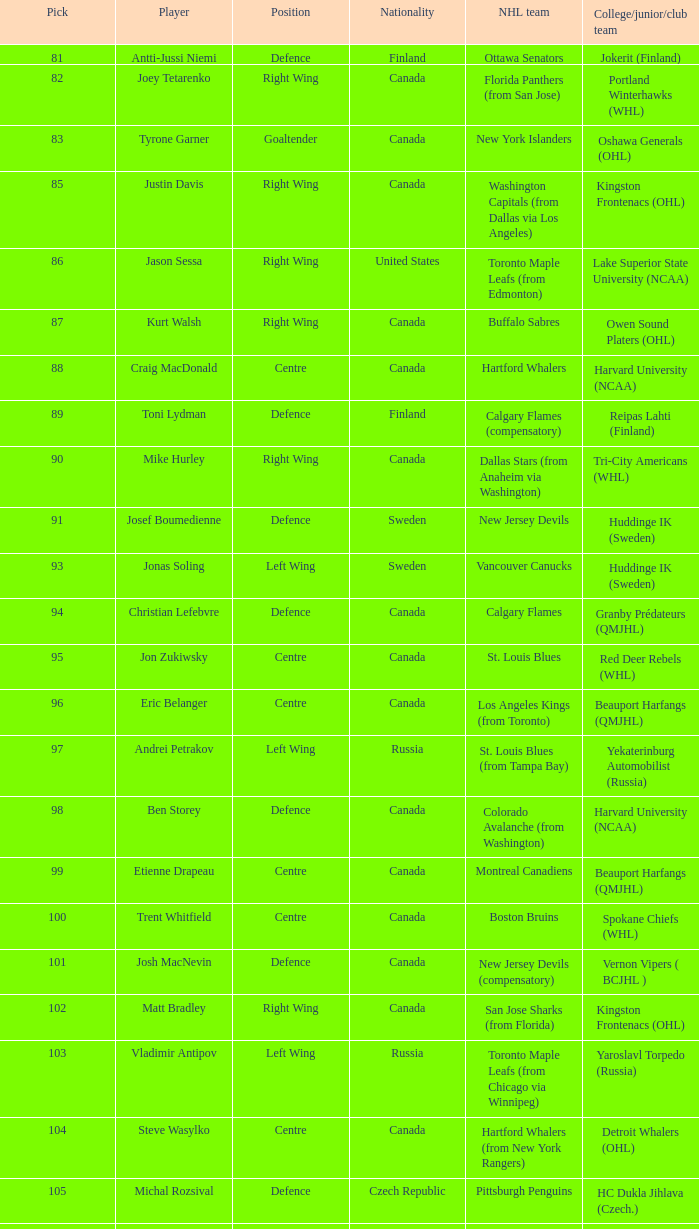What country does christian lefebvre come from? Canada. 